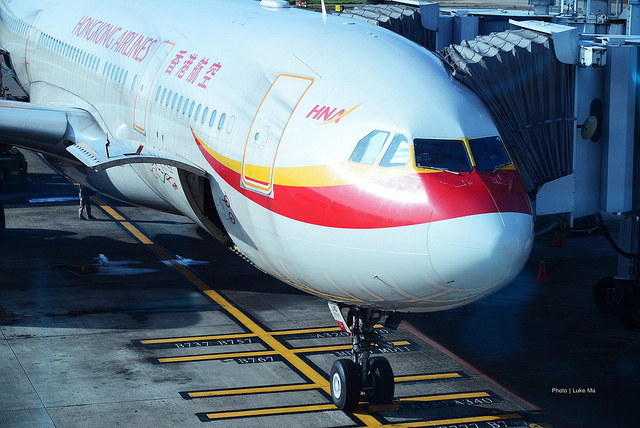Identify the text displayed in this image. AIRLINES HNA 4737 A340 